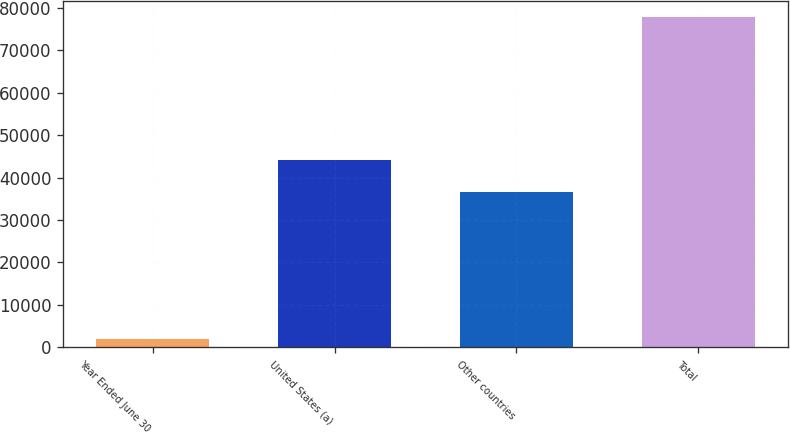Convert chart to OTSL. <chart><loc_0><loc_0><loc_500><loc_500><bar_chart><fcel>Year Ended June 30<fcel>United States (a)<fcel>Other countries<fcel>Total<nl><fcel>2013<fcel>44088.6<fcel>36505<fcel>77849<nl></chart> 